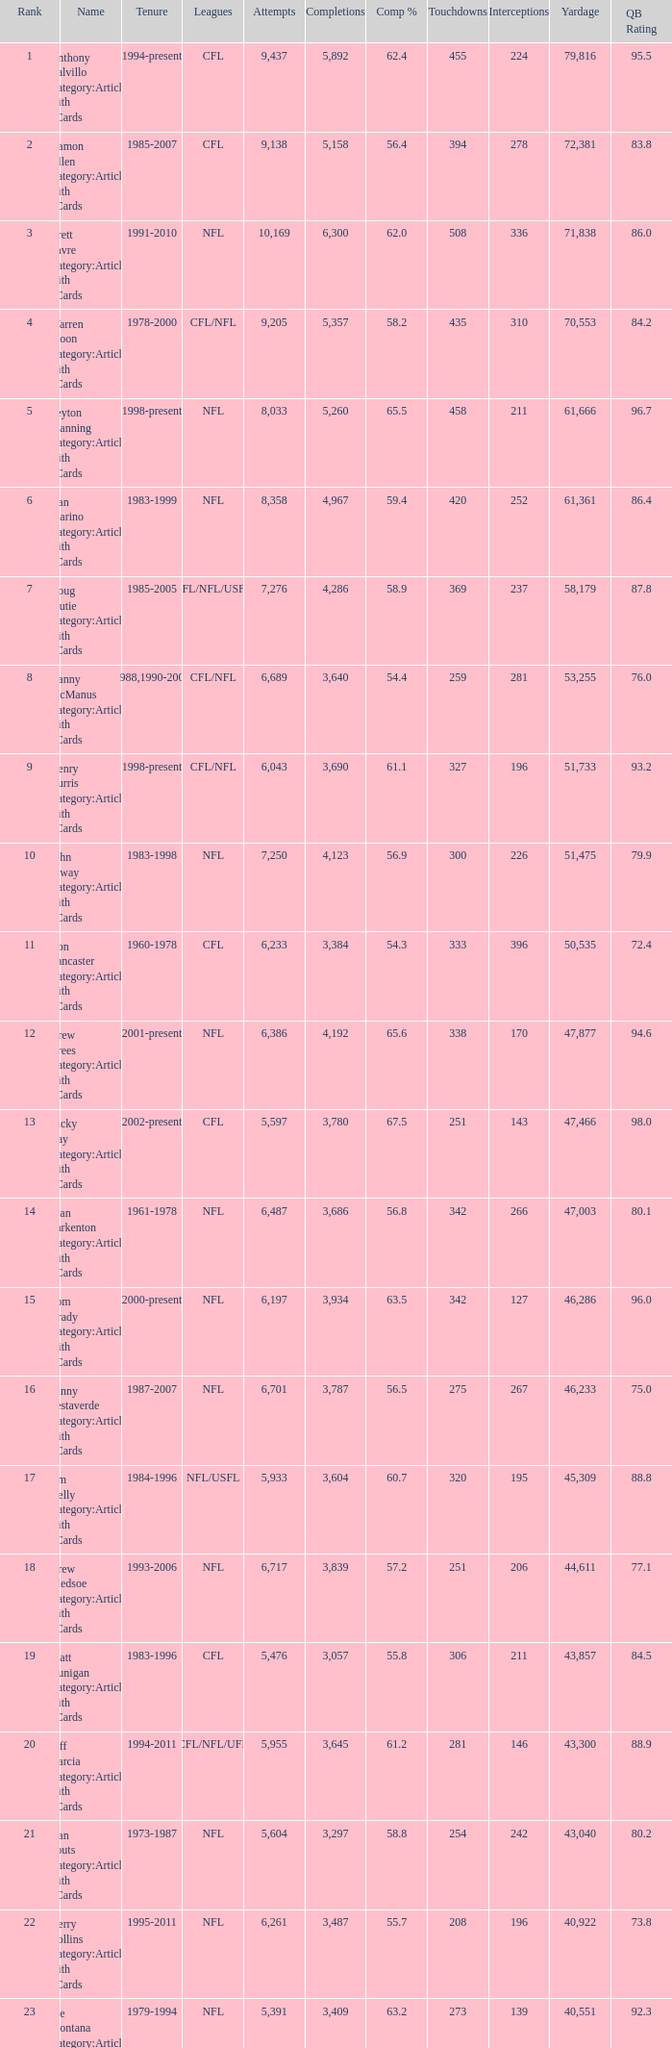What is the comp percentage when there are less than 44,611 in yardage, more than 254 touchdowns, and rank larger than 24? 54.6. 